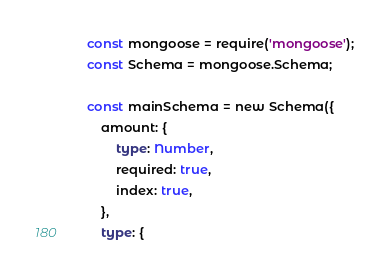Convert code to text. <code><loc_0><loc_0><loc_500><loc_500><_TypeScript_>const mongoose = require('mongoose');
const Schema = mongoose.Schema;

const mainSchema = new Schema({
	amount: {
		type: Number,
		required: true,
		index: true,
	},
	type: {</code> 